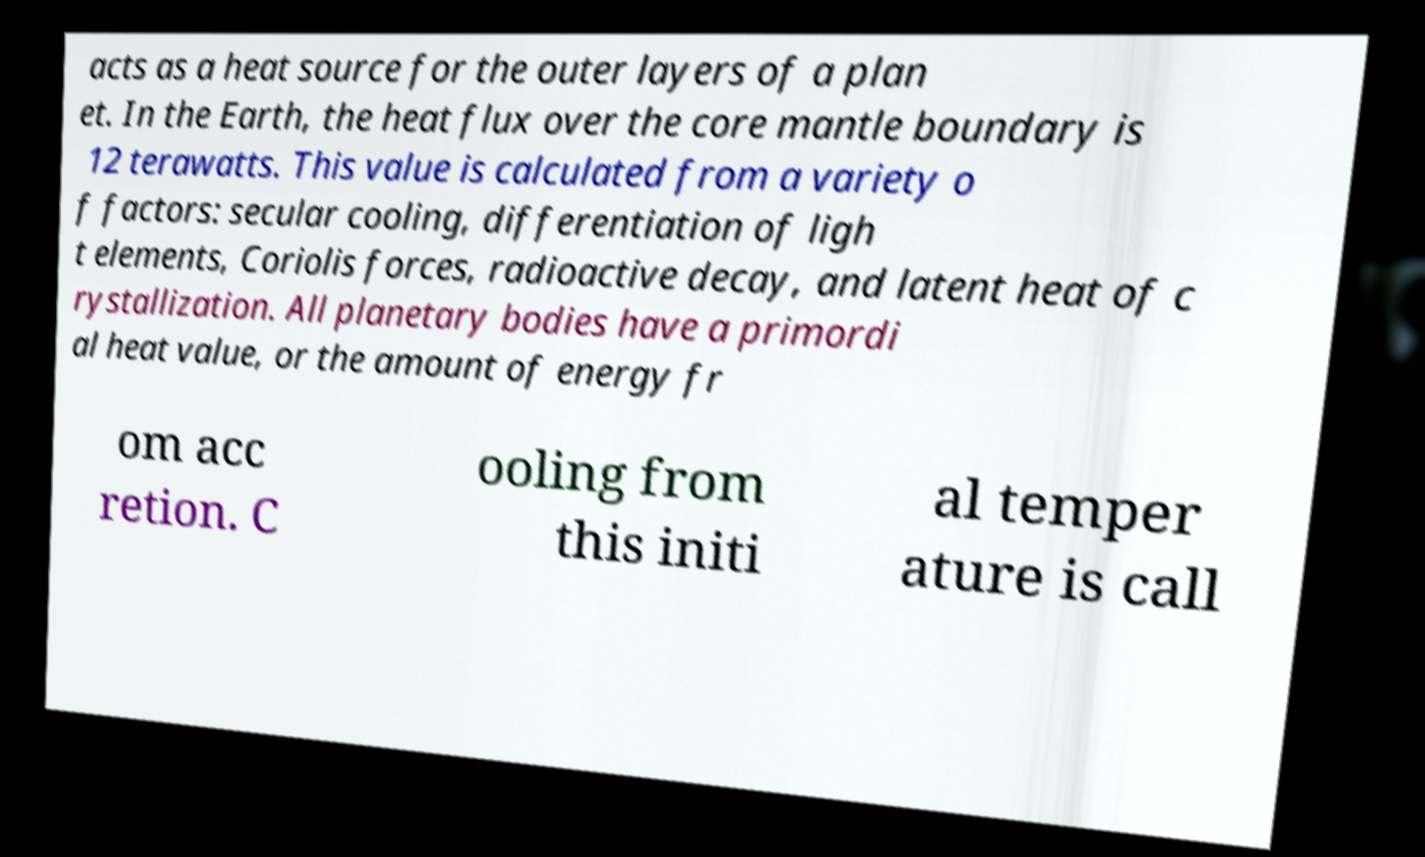I need the written content from this picture converted into text. Can you do that? acts as a heat source for the outer layers of a plan et. In the Earth, the heat flux over the core mantle boundary is 12 terawatts. This value is calculated from a variety o f factors: secular cooling, differentiation of ligh t elements, Coriolis forces, radioactive decay, and latent heat of c rystallization. All planetary bodies have a primordi al heat value, or the amount of energy fr om acc retion. C ooling from this initi al temper ature is call 